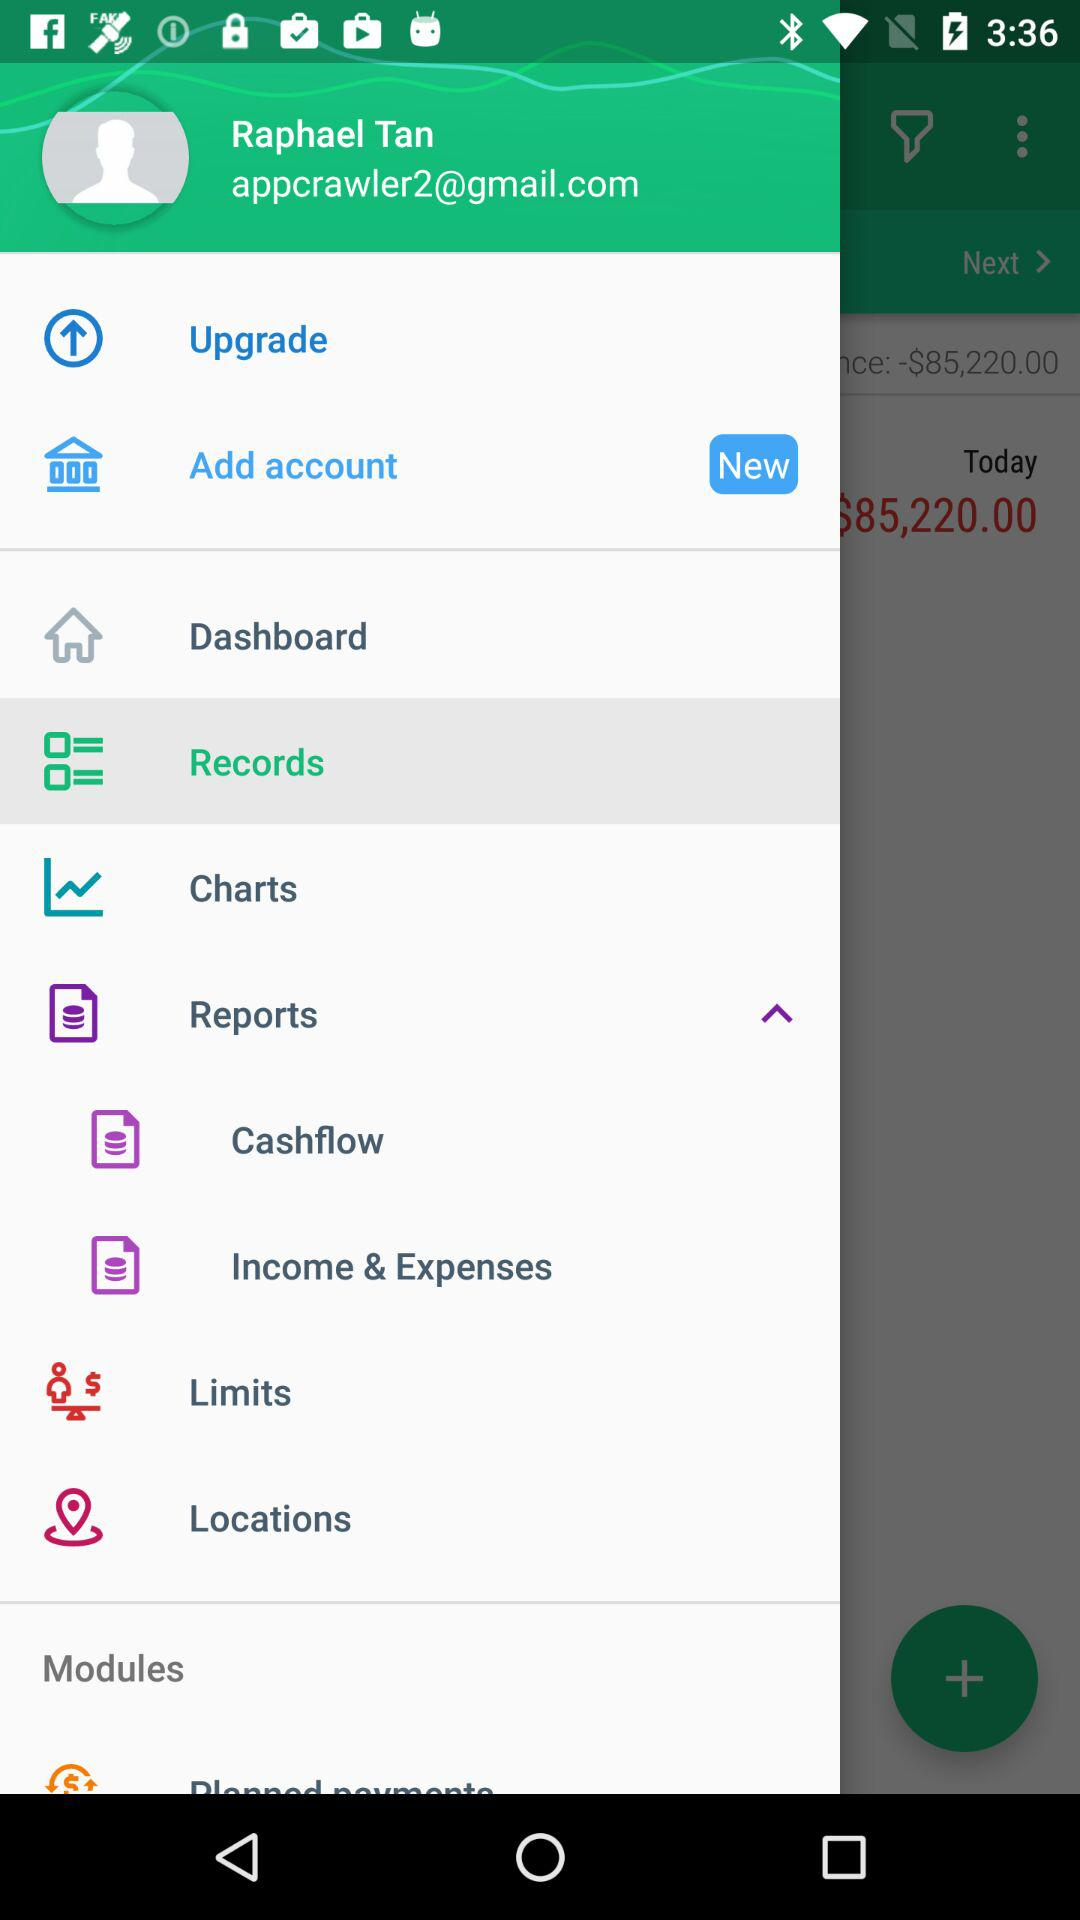How much money do I have in my account?
Answer the question using a single word or phrase. $85,220.00 